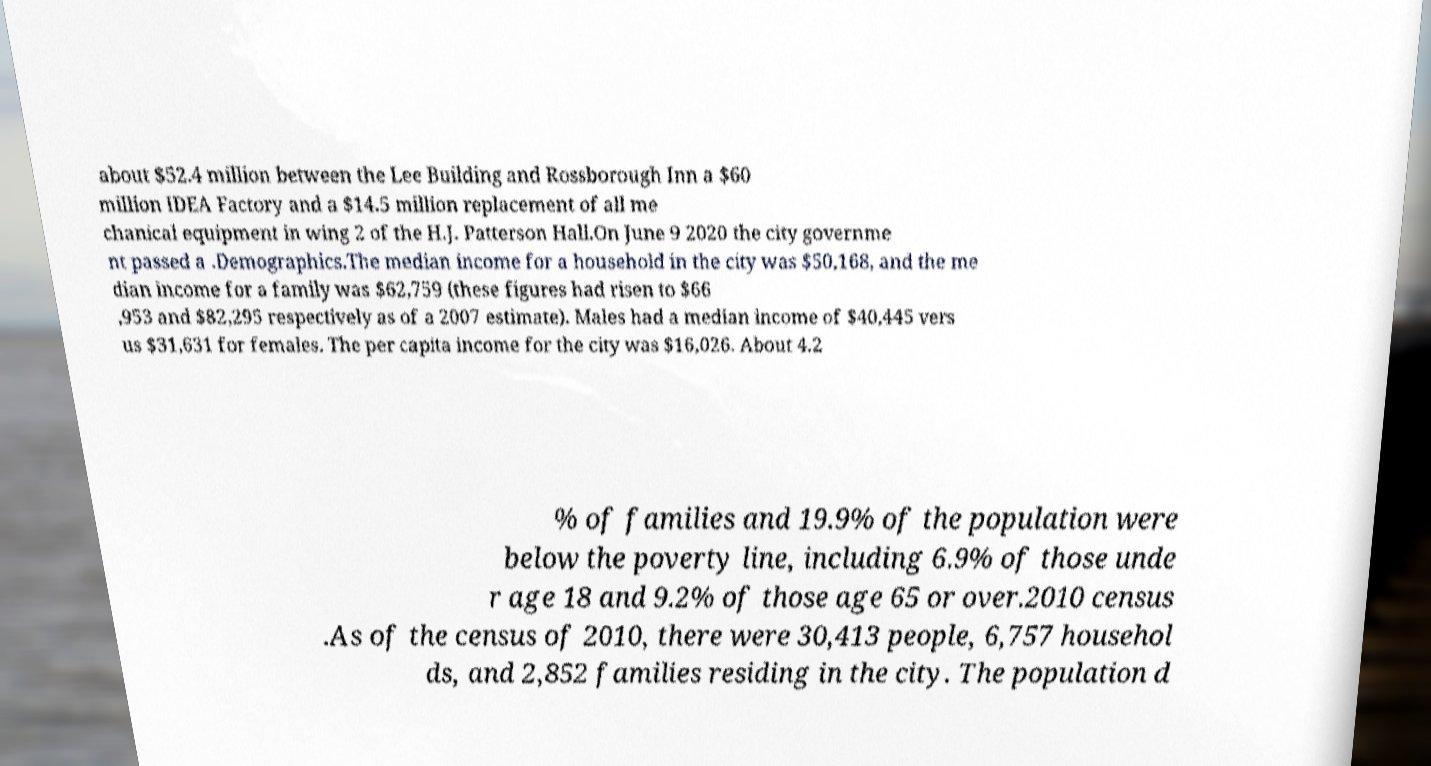For documentation purposes, I need the text within this image transcribed. Could you provide that? about $52.4 million between the Lee Building and Rossborough Inn a $60 million IDEA Factory and a $14.5 million replacement of all me chanical equipment in wing 2 of the H.J. Patterson Hall.On June 9 2020 the city governme nt passed a .Demographics.The median income for a household in the city was $50,168, and the me dian income for a family was $62,759 (these figures had risen to $66 ,953 and $82,295 respectively as of a 2007 estimate). Males had a median income of $40,445 vers us $31,631 for females. The per capita income for the city was $16,026. About 4.2 % of families and 19.9% of the population were below the poverty line, including 6.9% of those unde r age 18 and 9.2% of those age 65 or over.2010 census .As of the census of 2010, there were 30,413 people, 6,757 househol ds, and 2,852 families residing in the city. The population d 